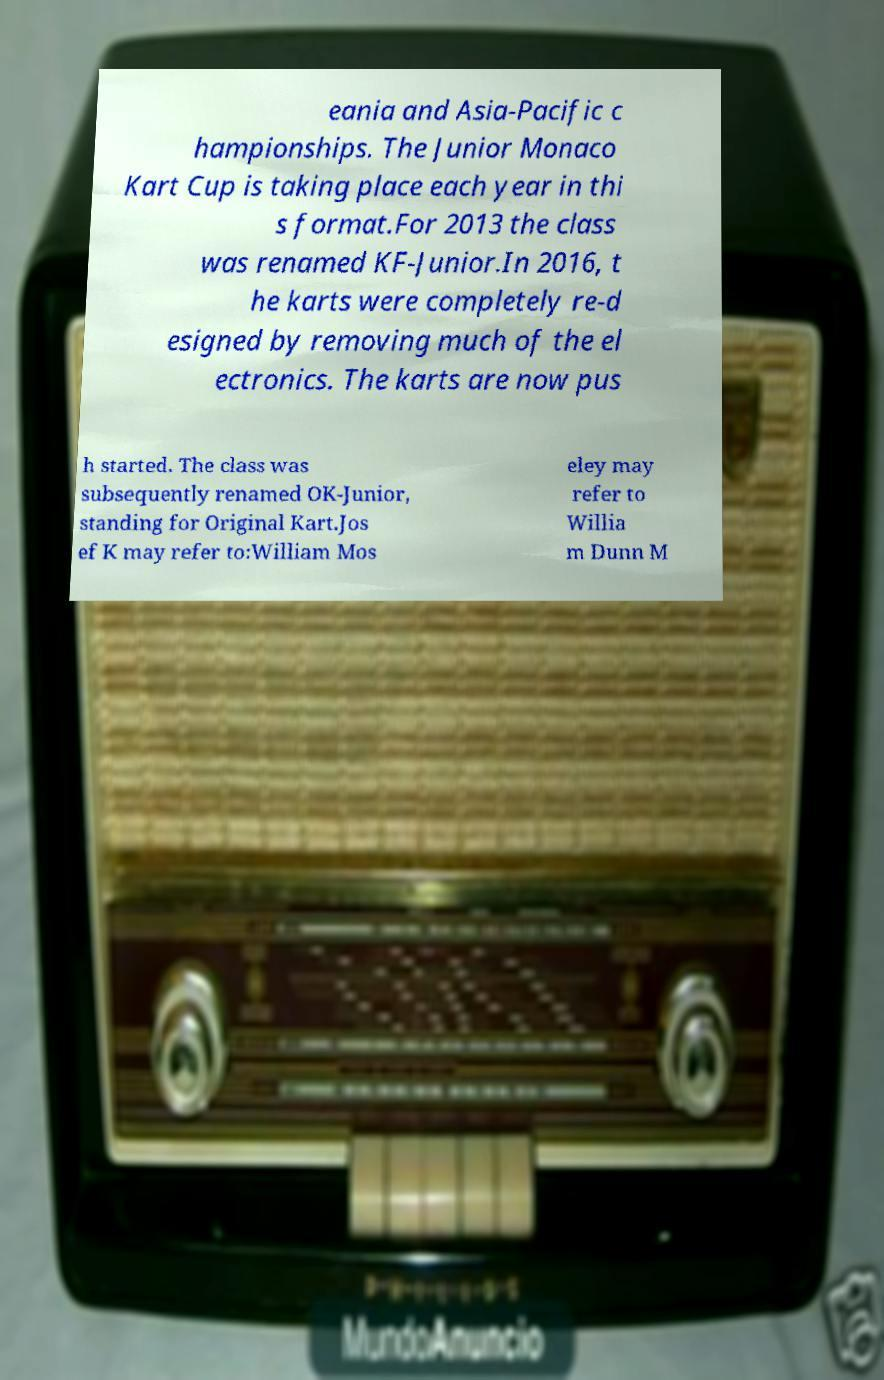Please identify and transcribe the text found in this image. eania and Asia-Pacific c hampionships. The Junior Monaco Kart Cup is taking place each year in thi s format.For 2013 the class was renamed KF-Junior.In 2016, t he karts were completely re-d esigned by removing much of the el ectronics. The karts are now pus h started. The class was subsequently renamed OK-Junior, standing for Original Kart.Jos ef K may refer to:William Mos eley may refer to Willia m Dunn M 